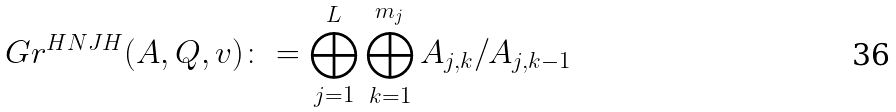Convert formula to latex. <formula><loc_0><loc_0><loc_500><loc_500>\ G r ^ { H N J H } ( A , Q , { v } ) \colon = \bigoplus _ { j = 1 } ^ { L } \bigoplus _ { k = 1 } ^ { m _ { j } } A _ { j , k } / A _ { j , k - 1 }</formula> 